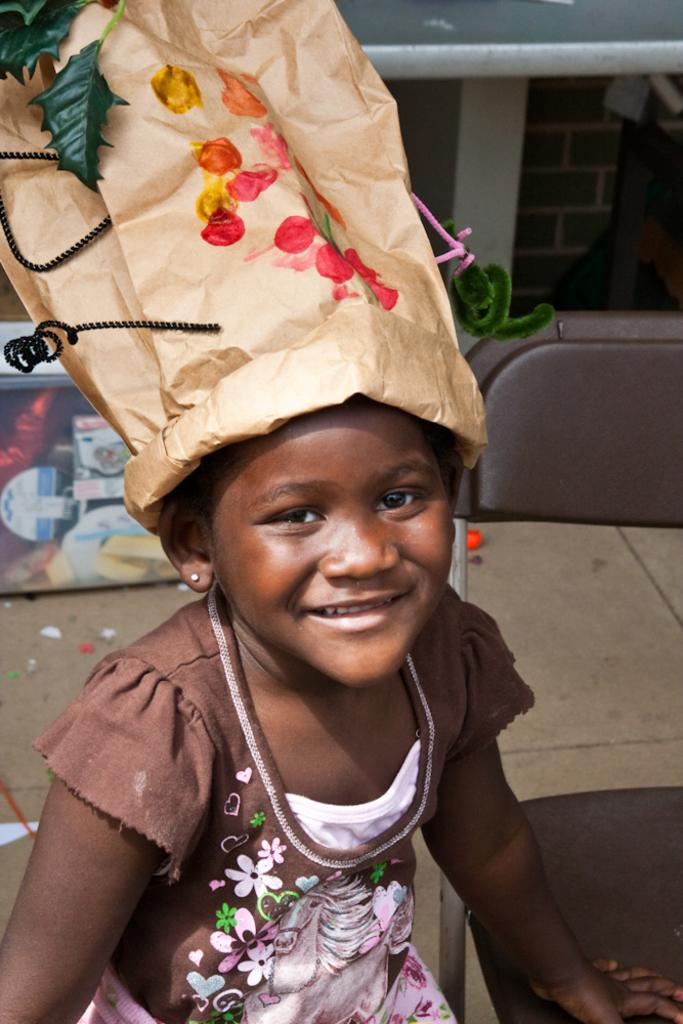What is the main subject of the picture? The main subject of the picture is a kid. What is the kid wearing? The kid is wearing a brown frock. What is on the kid's head? The kid has a paper bag with colors on her head. What is located beside the kid? There is a chair beside the kid. What type of muscle is visible on the kid's arm in the image? There is no muscle visible on the kid's arm in the image. Who is the owner of the chair beside the kid? The image does not provide information about the ownership of the chair. 